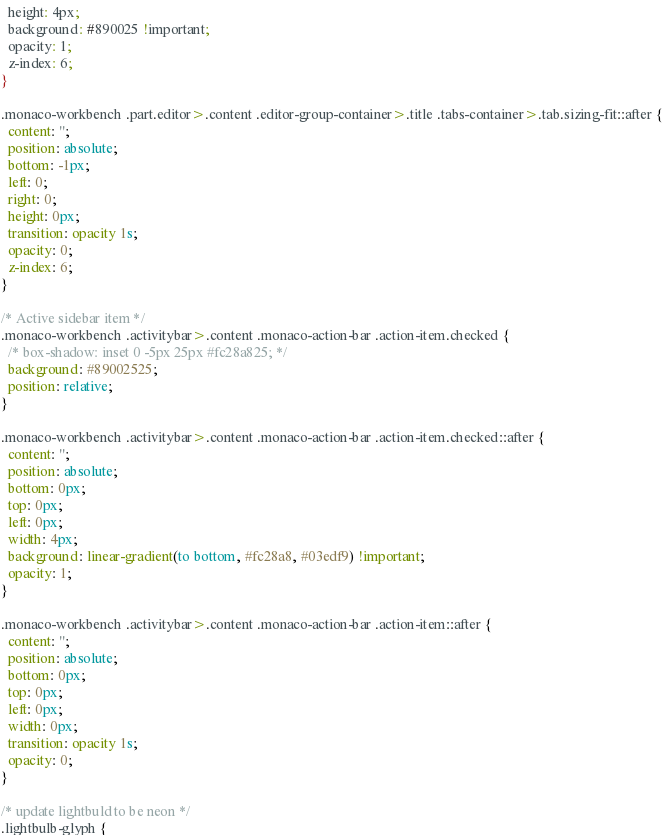Convert code to text. <code><loc_0><loc_0><loc_500><loc_500><_CSS_>  height: 4px;
  background: #890025 !important;
  opacity: 1;
  z-index: 6;
}

.monaco-workbench .part.editor>.content .editor-group-container>.title .tabs-container>.tab.sizing-fit::after {
  content: '';
  position: absolute;
  bottom: -1px;
  left: 0;
  right: 0;
  height: 0px;
  transition: opacity 1s;
  opacity: 0;
  z-index: 6;
}

/* Active sidebar item */
.monaco-workbench .activitybar>.content .monaco-action-bar .action-item.checked {
  /* box-shadow: inset 0 -5px 25px #fc28a825; */
  background: #89002525;
  position: relative;
}

.monaco-workbench .activitybar>.content .monaco-action-bar .action-item.checked::after {
  content: '';
  position: absolute;
  bottom: 0px;
  top: 0px;
  left: 0px;
  width: 4px;
  background: linear-gradient(to bottom, #fc28a8, #03edf9) !important;
  opacity: 1;
}

.monaco-workbench .activitybar>.content .monaco-action-bar .action-item::after {
  content: '';
  position: absolute;
  bottom: 0px;
  top: 0px;
  left: 0px;
  width: 0px;
  transition: opacity 1s;
  opacity: 0;
}

/* update lightbuld to be neon */
.lightbulb-glyph {</code> 